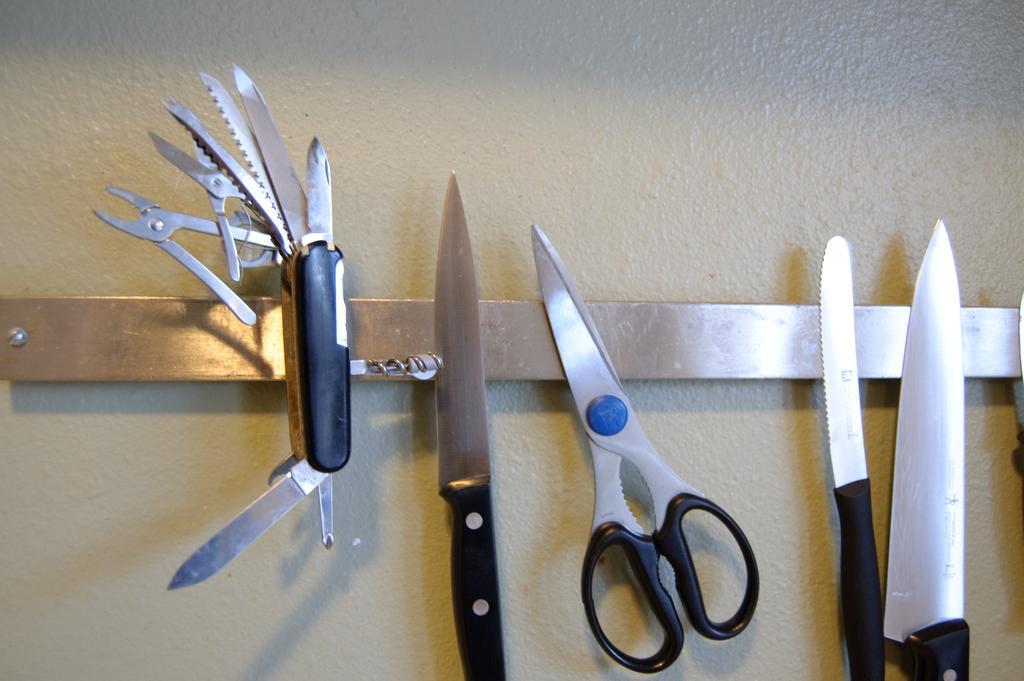How would you summarize this image in a sentence or two? In this picture there are knives and a scissors in the center of the image. 